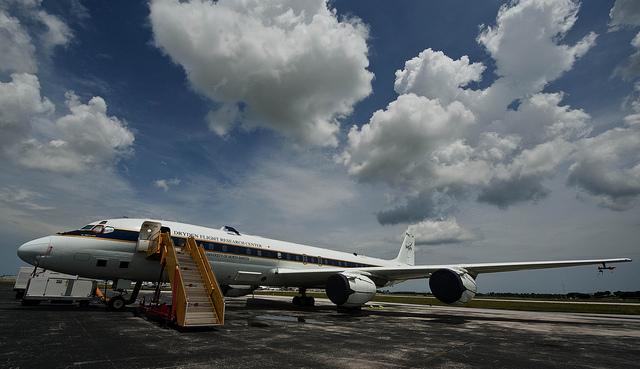Is this a new plane?
Concise answer only. Yes. Did the plane just land in the desert?
Answer briefly. No. Is this photo in color?
Answer briefly. Yes. What is in front of the plane door?
Short answer required. Stairs. Is there anyone inside the plane?
Answer briefly. No. Is this a vintage plane?
Concise answer only. No. Is there a ladder attached to the train?
Short answer required. No. How many propellers does this plane have?
Keep it brief. 0. Is there writing visible in this image?
Concise answer only. Yes. 